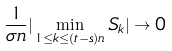<formula> <loc_0><loc_0><loc_500><loc_500>\frac { 1 } { \sigma n } | \min _ { 1 \leq k \leq ( t - s ) n } S _ { k } | \rightarrow 0</formula> 